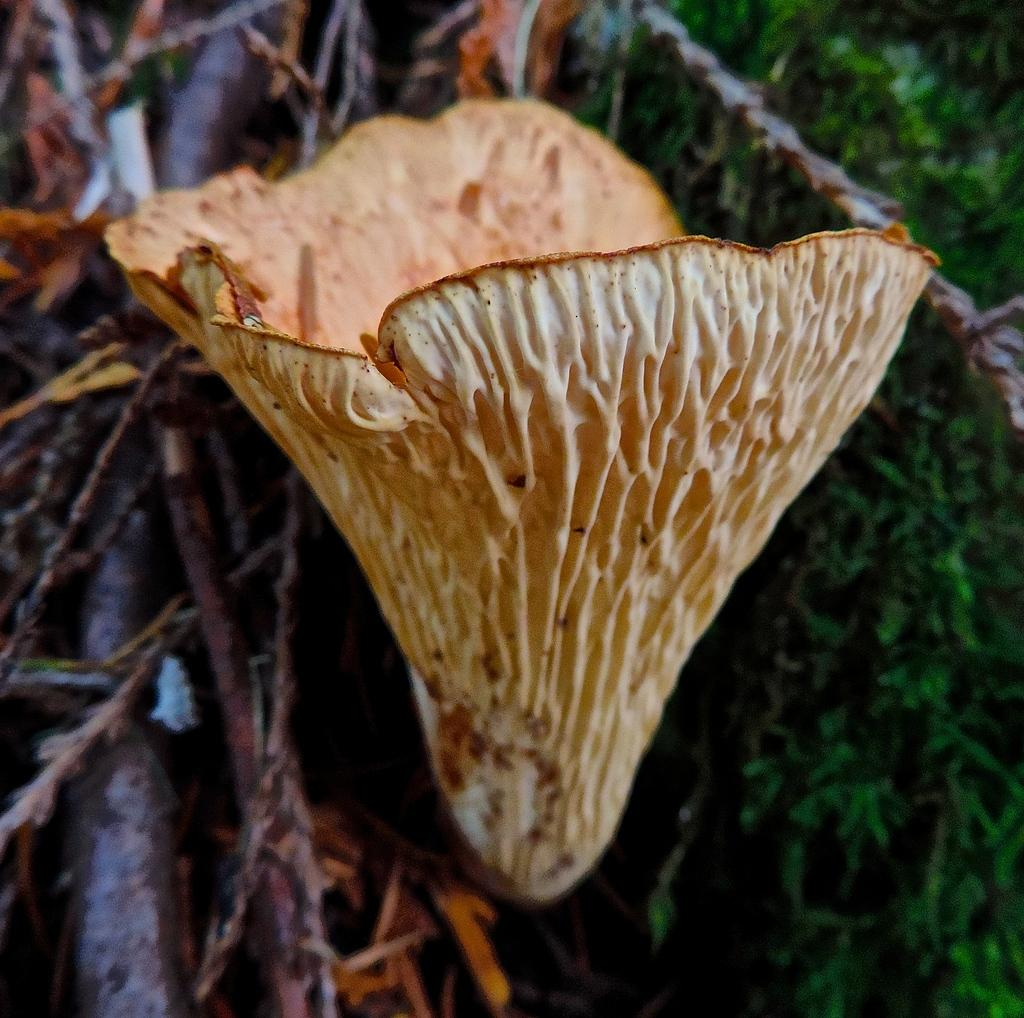What type of plant is featured in the image? There is a dry flower in the image. What type of vegetation can be seen in the background of the image? There is grass visible in the image. What other natural elements are present in the image? There are dry sticks in the image. What type of cough medicine is recommended for the dry flower in the image? There is no cough medicine needed for the dry flower in the image, as it is not a living organism that can experience a cough. 